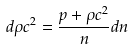<formula> <loc_0><loc_0><loc_500><loc_500>d \rho c ^ { 2 } = \frac { p + \rho c ^ { 2 } } { n } d n</formula> 